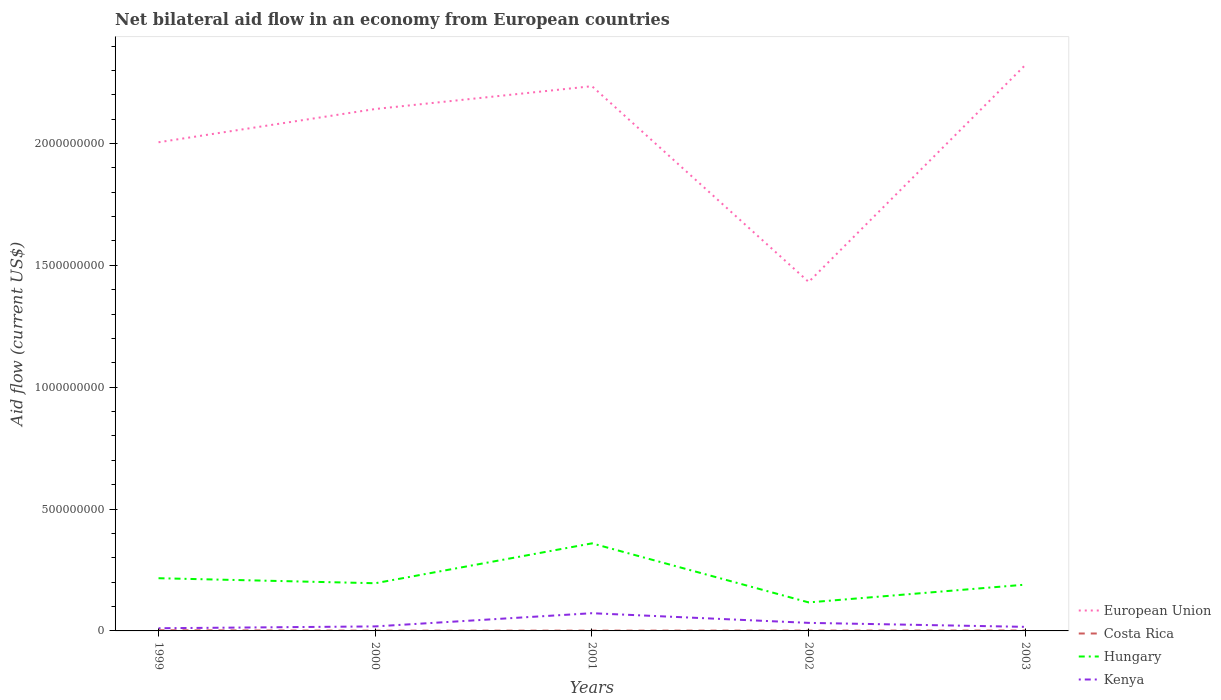Is the number of lines equal to the number of legend labels?
Your answer should be compact. Yes. Across all years, what is the maximum net bilateral aid flow in Hungary?
Your answer should be compact. 1.17e+08. What is the total net bilateral aid flow in Costa Rica in the graph?
Provide a short and direct response. 1.07e+06. What is the difference between the highest and the second highest net bilateral aid flow in Kenya?
Your response must be concise. 6.17e+07. What is the difference between the highest and the lowest net bilateral aid flow in Costa Rica?
Provide a succinct answer. 2. Is the net bilateral aid flow in Costa Rica strictly greater than the net bilateral aid flow in Hungary over the years?
Your answer should be compact. Yes. How many years are there in the graph?
Offer a very short reply. 5. Are the values on the major ticks of Y-axis written in scientific E-notation?
Your answer should be compact. No. Does the graph contain grids?
Provide a succinct answer. No. How many legend labels are there?
Your answer should be very brief. 4. What is the title of the graph?
Ensure brevity in your answer.  Net bilateral aid flow in an economy from European countries. Does "Slovenia" appear as one of the legend labels in the graph?
Your answer should be very brief. No. What is the Aid flow (current US$) in European Union in 1999?
Your answer should be compact. 2.01e+09. What is the Aid flow (current US$) of Costa Rica in 1999?
Make the answer very short. 2.82e+06. What is the Aid flow (current US$) of Hungary in 1999?
Your answer should be compact. 2.16e+08. What is the Aid flow (current US$) of Kenya in 1999?
Provide a short and direct response. 1.10e+07. What is the Aid flow (current US$) in European Union in 2000?
Keep it short and to the point. 2.14e+09. What is the Aid flow (current US$) in Costa Rica in 2000?
Provide a succinct answer. 1.12e+06. What is the Aid flow (current US$) of Hungary in 2000?
Give a very brief answer. 1.96e+08. What is the Aid flow (current US$) in Kenya in 2000?
Give a very brief answer. 1.86e+07. What is the Aid flow (current US$) in European Union in 2001?
Your response must be concise. 2.24e+09. What is the Aid flow (current US$) in Costa Rica in 2001?
Offer a very short reply. 1.27e+06. What is the Aid flow (current US$) in Hungary in 2001?
Your answer should be very brief. 3.59e+08. What is the Aid flow (current US$) in Kenya in 2001?
Your response must be concise. 7.27e+07. What is the Aid flow (current US$) of European Union in 2002?
Offer a terse response. 1.43e+09. What is the Aid flow (current US$) in Costa Rica in 2002?
Keep it short and to the point. 1.42e+06. What is the Aid flow (current US$) of Hungary in 2002?
Your answer should be compact. 1.17e+08. What is the Aid flow (current US$) of Kenya in 2002?
Offer a terse response. 3.30e+07. What is the Aid flow (current US$) of European Union in 2003?
Your answer should be compact. 2.32e+09. What is the Aid flow (current US$) of Costa Rica in 2003?
Provide a short and direct response. 1.75e+06. What is the Aid flow (current US$) of Hungary in 2003?
Make the answer very short. 1.90e+08. What is the Aid flow (current US$) in Kenya in 2003?
Offer a very short reply. 1.67e+07. Across all years, what is the maximum Aid flow (current US$) in European Union?
Your answer should be very brief. 2.32e+09. Across all years, what is the maximum Aid flow (current US$) of Costa Rica?
Offer a terse response. 2.82e+06. Across all years, what is the maximum Aid flow (current US$) of Hungary?
Your answer should be compact. 3.59e+08. Across all years, what is the maximum Aid flow (current US$) of Kenya?
Make the answer very short. 7.27e+07. Across all years, what is the minimum Aid flow (current US$) of European Union?
Your answer should be very brief. 1.43e+09. Across all years, what is the minimum Aid flow (current US$) in Costa Rica?
Your response must be concise. 1.12e+06. Across all years, what is the minimum Aid flow (current US$) in Hungary?
Offer a terse response. 1.17e+08. Across all years, what is the minimum Aid flow (current US$) of Kenya?
Provide a succinct answer. 1.10e+07. What is the total Aid flow (current US$) in European Union in the graph?
Offer a very short reply. 1.01e+1. What is the total Aid flow (current US$) of Costa Rica in the graph?
Ensure brevity in your answer.  8.38e+06. What is the total Aid flow (current US$) of Hungary in the graph?
Offer a very short reply. 1.08e+09. What is the total Aid flow (current US$) of Kenya in the graph?
Your answer should be compact. 1.52e+08. What is the difference between the Aid flow (current US$) of European Union in 1999 and that in 2000?
Give a very brief answer. -1.36e+08. What is the difference between the Aid flow (current US$) in Costa Rica in 1999 and that in 2000?
Keep it short and to the point. 1.70e+06. What is the difference between the Aid flow (current US$) in Hungary in 1999 and that in 2000?
Your answer should be compact. 2.06e+07. What is the difference between the Aid flow (current US$) in Kenya in 1999 and that in 2000?
Provide a short and direct response. -7.58e+06. What is the difference between the Aid flow (current US$) in European Union in 1999 and that in 2001?
Offer a terse response. -2.30e+08. What is the difference between the Aid flow (current US$) of Costa Rica in 1999 and that in 2001?
Provide a short and direct response. 1.55e+06. What is the difference between the Aid flow (current US$) in Hungary in 1999 and that in 2001?
Your response must be concise. -1.43e+08. What is the difference between the Aid flow (current US$) of Kenya in 1999 and that in 2001?
Your response must be concise. -6.17e+07. What is the difference between the Aid flow (current US$) of European Union in 1999 and that in 2002?
Provide a succinct answer. 5.73e+08. What is the difference between the Aid flow (current US$) in Costa Rica in 1999 and that in 2002?
Give a very brief answer. 1.40e+06. What is the difference between the Aid flow (current US$) in Hungary in 1999 and that in 2002?
Offer a terse response. 9.93e+07. What is the difference between the Aid flow (current US$) of Kenya in 1999 and that in 2002?
Offer a terse response. -2.21e+07. What is the difference between the Aid flow (current US$) of European Union in 1999 and that in 2003?
Your answer should be compact. -3.18e+08. What is the difference between the Aid flow (current US$) in Costa Rica in 1999 and that in 2003?
Your answer should be compact. 1.07e+06. What is the difference between the Aid flow (current US$) in Hungary in 1999 and that in 2003?
Offer a very short reply. 2.64e+07. What is the difference between the Aid flow (current US$) in Kenya in 1999 and that in 2003?
Give a very brief answer. -5.70e+06. What is the difference between the Aid flow (current US$) in European Union in 2000 and that in 2001?
Your answer should be very brief. -9.36e+07. What is the difference between the Aid flow (current US$) in Costa Rica in 2000 and that in 2001?
Your response must be concise. -1.50e+05. What is the difference between the Aid flow (current US$) in Hungary in 2000 and that in 2001?
Offer a very short reply. -1.64e+08. What is the difference between the Aid flow (current US$) of Kenya in 2000 and that in 2001?
Ensure brevity in your answer.  -5.41e+07. What is the difference between the Aid flow (current US$) in European Union in 2000 and that in 2002?
Provide a succinct answer. 7.10e+08. What is the difference between the Aid flow (current US$) of Costa Rica in 2000 and that in 2002?
Ensure brevity in your answer.  -3.00e+05. What is the difference between the Aid flow (current US$) of Hungary in 2000 and that in 2002?
Your answer should be compact. 7.87e+07. What is the difference between the Aid flow (current US$) of Kenya in 2000 and that in 2002?
Make the answer very short. -1.45e+07. What is the difference between the Aid flow (current US$) of European Union in 2000 and that in 2003?
Provide a succinct answer. -1.81e+08. What is the difference between the Aid flow (current US$) in Costa Rica in 2000 and that in 2003?
Give a very brief answer. -6.30e+05. What is the difference between the Aid flow (current US$) in Hungary in 2000 and that in 2003?
Your response must be concise. 5.76e+06. What is the difference between the Aid flow (current US$) in Kenya in 2000 and that in 2003?
Offer a very short reply. 1.88e+06. What is the difference between the Aid flow (current US$) of European Union in 2001 and that in 2002?
Your response must be concise. 8.03e+08. What is the difference between the Aid flow (current US$) in Costa Rica in 2001 and that in 2002?
Provide a succinct answer. -1.50e+05. What is the difference between the Aid flow (current US$) in Hungary in 2001 and that in 2002?
Your response must be concise. 2.42e+08. What is the difference between the Aid flow (current US$) of Kenya in 2001 and that in 2002?
Make the answer very short. 3.97e+07. What is the difference between the Aid flow (current US$) of European Union in 2001 and that in 2003?
Offer a very short reply. -8.75e+07. What is the difference between the Aid flow (current US$) in Costa Rica in 2001 and that in 2003?
Make the answer very short. -4.80e+05. What is the difference between the Aid flow (current US$) in Hungary in 2001 and that in 2003?
Give a very brief answer. 1.69e+08. What is the difference between the Aid flow (current US$) of Kenya in 2001 and that in 2003?
Ensure brevity in your answer.  5.60e+07. What is the difference between the Aid flow (current US$) of European Union in 2002 and that in 2003?
Your answer should be compact. -8.91e+08. What is the difference between the Aid flow (current US$) in Costa Rica in 2002 and that in 2003?
Make the answer very short. -3.30e+05. What is the difference between the Aid flow (current US$) in Hungary in 2002 and that in 2003?
Make the answer very short. -7.29e+07. What is the difference between the Aid flow (current US$) of Kenya in 2002 and that in 2003?
Your answer should be compact. 1.64e+07. What is the difference between the Aid flow (current US$) of European Union in 1999 and the Aid flow (current US$) of Costa Rica in 2000?
Keep it short and to the point. 2.00e+09. What is the difference between the Aid flow (current US$) in European Union in 1999 and the Aid flow (current US$) in Hungary in 2000?
Your response must be concise. 1.81e+09. What is the difference between the Aid flow (current US$) of European Union in 1999 and the Aid flow (current US$) of Kenya in 2000?
Offer a terse response. 1.99e+09. What is the difference between the Aid flow (current US$) in Costa Rica in 1999 and the Aid flow (current US$) in Hungary in 2000?
Provide a succinct answer. -1.93e+08. What is the difference between the Aid flow (current US$) of Costa Rica in 1999 and the Aid flow (current US$) of Kenya in 2000?
Keep it short and to the point. -1.57e+07. What is the difference between the Aid flow (current US$) in Hungary in 1999 and the Aid flow (current US$) in Kenya in 2000?
Give a very brief answer. 1.98e+08. What is the difference between the Aid flow (current US$) of European Union in 1999 and the Aid flow (current US$) of Costa Rica in 2001?
Provide a succinct answer. 2.00e+09. What is the difference between the Aid flow (current US$) in European Union in 1999 and the Aid flow (current US$) in Hungary in 2001?
Your answer should be very brief. 1.65e+09. What is the difference between the Aid flow (current US$) of European Union in 1999 and the Aid flow (current US$) of Kenya in 2001?
Offer a terse response. 1.93e+09. What is the difference between the Aid flow (current US$) in Costa Rica in 1999 and the Aid flow (current US$) in Hungary in 2001?
Your response must be concise. -3.56e+08. What is the difference between the Aid flow (current US$) in Costa Rica in 1999 and the Aid flow (current US$) in Kenya in 2001?
Give a very brief answer. -6.99e+07. What is the difference between the Aid flow (current US$) in Hungary in 1999 and the Aid flow (current US$) in Kenya in 2001?
Keep it short and to the point. 1.44e+08. What is the difference between the Aid flow (current US$) of European Union in 1999 and the Aid flow (current US$) of Costa Rica in 2002?
Give a very brief answer. 2.00e+09. What is the difference between the Aid flow (current US$) in European Union in 1999 and the Aid flow (current US$) in Hungary in 2002?
Make the answer very short. 1.89e+09. What is the difference between the Aid flow (current US$) of European Union in 1999 and the Aid flow (current US$) of Kenya in 2002?
Your response must be concise. 1.97e+09. What is the difference between the Aid flow (current US$) in Costa Rica in 1999 and the Aid flow (current US$) in Hungary in 2002?
Provide a succinct answer. -1.14e+08. What is the difference between the Aid flow (current US$) of Costa Rica in 1999 and the Aid flow (current US$) of Kenya in 2002?
Your answer should be compact. -3.02e+07. What is the difference between the Aid flow (current US$) in Hungary in 1999 and the Aid flow (current US$) in Kenya in 2002?
Ensure brevity in your answer.  1.83e+08. What is the difference between the Aid flow (current US$) in European Union in 1999 and the Aid flow (current US$) in Costa Rica in 2003?
Ensure brevity in your answer.  2.00e+09. What is the difference between the Aid flow (current US$) in European Union in 1999 and the Aid flow (current US$) in Hungary in 2003?
Keep it short and to the point. 1.82e+09. What is the difference between the Aid flow (current US$) of European Union in 1999 and the Aid flow (current US$) of Kenya in 2003?
Provide a succinct answer. 1.99e+09. What is the difference between the Aid flow (current US$) in Costa Rica in 1999 and the Aid flow (current US$) in Hungary in 2003?
Offer a terse response. -1.87e+08. What is the difference between the Aid flow (current US$) in Costa Rica in 1999 and the Aid flow (current US$) in Kenya in 2003?
Keep it short and to the point. -1.38e+07. What is the difference between the Aid flow (current US$) of Hungary in 1999 and the Aid flow (current US$) of Kenya in 2003?
Offer a terse response. 2.00e+08. What is the difference between the Aid flow (current US$) in European Union in 2000 and the Aid flow (current US$) in Costa Rica in 2001?
Provide a succinct answer. 2.14e+09. What is the difference between the Aid flow (current US$) in European Union in 2000 and the Aid flow (current US$) in Hungary in 2001?
Give a very brief answer. 1.78e+09. What is the difference between the Aid flow (current US$) of European Union in 2000 and the Aid flow (current US$) of Kenya in 2001?
Keep it short and to the point. 2.07e+09. What is the difference between the Aid flow (current US$) of Costa Rica in 2000 and the Aid flow (current US$) of Hungary in 2001?
Give a very brief answer. -3.58e+08. What is the difference between the Aid flow (current US$) in Costa Rica in 2000 and the Aid flow (current US$) in Kenya in 2001?
Your answer should be very brief. -7.16e+07. What is the difference between the Aid flow (current US$) of Hungary in 2000 and the Aid flow (current US$) of Kenya in 2001?
Provide a short and direct response. 1.23e+08. What is the difference between the Aid flow (current US$) in European Union in 2000 and the Aid flow (current US$) in Costa Rica in 2002?
Ensure brevity in your answer.  2.14e+09. What is the difference between the Aid flow (current US$) in European Union in 2000 and the Aid flow (current US$) in Hungary in 2002?
Ensure brevity in your answer.  2.02e+09. What is the difference between the Aid flow (current US$) of European Union in 2000 and the Aid flow (current US$) of Kenya in 2002?
Give a very brief answer. 2.11e+09. What is the difference between the Aid flow (current US$) in Costa Rica in 2000 and the Aid flow (current US$) in Hungary in 2002?
Offer a very short reply. -1.16e+08. What is the difference between the Aid flow (current US$) in Costa Rica in 2000 and the Aid flow (current US$) in Kenya in 2002?
Give a very brief answer. -3.19e+07. What is the difference between the Aid flow (current US$) in Hungary in 2000 and the Aid flow (current US$) in Kenya in 2002?
Ensure brevity in your answer.  1.63e+08. What is the difference between the Aid flow (current US$) in European Union in 2000 and the Aid flow (current US$) in Costa Rica in 2003?
Your response must be concise. 2.14e+09. What is the difference between the Aid flow (current US$) of European Union in 2000 and the Aid flow (current US$) of Hungary in 2003?
Offer a very short reply. 1.95e+09. What is the difference between the Aid flow (current US$) in European Union in 2000 and the Aid flow (current US$) in Kenya in 2003?
Ensure brevity in your answer.  2.12e+09. What is the difference between the Aid flow (current US$) in Costa Rica in 2000 and the Aid flow (current US$) in Hungary in 2003?
Ensure brevity in your answer.  -1.89e+08. What is the difference between the Aid flow (current US$) in Costa Rica in 2000 and the Aid flow (current US$) in Kenya in 2003?
Keep it short and to the point. -1.56e+07. What is the difference between the Aid flow (current US$) of Hungary in 2000 and the Aid flow (current US$) of Kenya in 2003?
Keep it short and to the point. 1.79e+08. What is the difference between the Aid flow (current US$) of European Union in 2001 and the Aid flow (current US$) of Costa Rica in 2002?
Give a very brief answer. 2.23e+09. What is the difference between the Aid flow (current US$) of European Union in 2001 and the Aid flow (current US$) of Hungary in 2002?
Provide a short and direct response. 2.12e+09. What is the difference between the Aid flow (current US$) of European Union in 2001 and the Aid flow (current US$) of Kenya in 2002?
Your answer should be compact. 2.20e+09. What is the difference between the Aid flow (current US$) of Costa Rica in 2001 and the Aid flow (current US$) of Hungary in 2002?
Ensure brevity in your answer.  -1.16e+08. What is the difference between the Aid flow (current US$) in Costa Rica in 2001 and the Aid flow (current US$) in Kenya in 2002?
Your response must be concise. -3.18e+07. What is the difference between the Aid flow (current US$) in Hungary in 2001 and the Aid flow (current US$) in Kenya in 2002?
Provide a short and direct response. 3.26e+08. What is the difference between the Aid flow (current US$) in European Union in 2001 and the Aid flow (current US$) in Costa Rica in 2003?
Offer a terse response. 2.23e+09. What is the difference between the Aid flow (current US$) in European Union in 2001 and the Aid flow (current US$) in Hungary in 2003?
Give a very brief answer. 2.05e+09. What is the difference between the Aid flow (current US$) of European Union in 2001 and the Aid flow (current US$) of Kenya in 2003?
Keep it short and to the point. 2.22e+09. What is the difference between the Aid flow (current US$) of Costa Rica in 2001 and the Aid flow (current US$) of Hungary in 2003?
Offer a terse response. -1.89e+08. What is the difference between the Aid flow (current US$) in Costa Rica in 2001 and the Aid flow (current US$) in Kenya in 2003?
Give a very brief answer. -1.54e+07. What is the difference between the Aid flow (current US$) of Hungary in 2001 and the Aid flow (current US$) of Kenya in 2003?
Provide a succinct answer. 3.43e+08. What is the difference between the Aid flow (current US$) of European Union in 2002 and the Aid flow (current US$) of Costa Rica in 2003?
Make the answer very short. 1.43e+09. What is the difference between the Aid flow (current US$) of European Union in 2002 and the Aid flow (current US$) of Hungary in 2003?
Provide a short and direct response. 1.24e+09. What is the difference between the Aid flow (current US$) of European Union in 2002 and the Aid flow (current US$) of Kenya in 2003?
Keep it short and to the point. 1.42e+09. What is the difference between the Aid flow (current US$) of Costa Rica in 2002 and the Aid flow (current US$) of Hungary in 2003?
Make the answer very short. -1.88e+08. What is the difference between the Aid flow (current US$) of Costa Rica in 2002 and the Aid flow (current US$) of Kenya in 2003?
Your answer should be very brief. -1.52e+07. What is the difference between the Aid flow (current US$) in Hungary in 2002 and the Aid flow (current US$) in Kenya in 2003?
Your answer should be compact. 1.00e+08. What is the average Aid flow (current US$) of European Union per year?
Offer a terse response. 2.03e+09. What is the average Aid flow (current US$) in Costa Rica per year?
Provide a succinct answer. 1.68e+06. What is the average Aid flow (current US$) of Hungary per year?
Give a very brief answer. 2.16e+08. What is the average Aid flow (current US$) of Kenya per year?
Offer a terse response. 3.04e+07. In the year 1999, what is the difference between the Aid flow (current US$) of European Union and Aid flow (current US$) of Costa Rica?
Ensure brevity in your answer.  2.00e+09. In the year 1999, what is the difference between the Aid flow (current US$) of European Union and Aid flow (current US$) of Hungary?
Keep it short and to the point. 1.79e+09. In the year 1999, what is the difference between the Aid flow (current US$) in European Union and Aid flow (current US$) in Kenya?
Offer a very short reply. 1.99e+09. In the year 1999, what is the difference between the Aid flow (current US$) of Costa Rica and Aid flow (current US$) of Hungary?
Your answer should be compact. -2.13e+08. In the year 1999, what is the difference between the Aid flow (current US$) of Costa Rica and Aid flow (current US$) of Kenya?
Make the answer very short. -8.15e+06. In the year 1999, what is the difference between the Aid flow (current US$) in Hungary and Aid flow (current US$) in Kenya?
Make the answer very short. 2.05e+08. In the year 2000, what is the difference between the Aid flow (current US$) of European Union and Aid flow (current US$) of Costa Rica?
Your response must be concise. 2.14e+09. In the year 2000, what is the difference between the Aid flow (current US$) in European Union and Aid flow (current US$) in Hungary?
Your response must be concise. 1.95e+09. In the year 2000, what is the difference between the Aid flow (current US$) of European Union and Aid flow (current US$) of Kenya?
Your response must be concise. 2.12e+09. In the year 2000, what is the difference between the Aid flow (current US$) in Costa Rica and Aid flow (current US$) in Hungary?
Provide a short and direct response. -1.95e+08. In the year 2000, what is the difference between the Aid flow (current US$) of Costa Rica and Aid flow (current US$) of Kenya?
Make the answer very short. -1.74e+07. In the year 2000, what is the difference between the Aid flow (current US$) of Hungary and Aid flow (current US$) of Kenya?
Make the answer very short. 1.77e+08. In the year 2001, what is the difference between the Aid flow (current US$) in European Union and Aid flow (current US$) in Costa Rica?
Keep it short and to the point. 2.23e+09. In the year 2001, what is the difference between the Aid flow (current US$) of European Union and Aid flow (current US$) of Hungary?
Your answer should be very brief. 1.88e+09. In the year 2001, what is the difference between the Aid flow (current US$) in European Union and Aid flow (current US$) in Kenya?
Provide a succinct answer. 2.16e+09. In the year 2001, what is the difference between the Aid flow (current US$) in Costa Rica and Aid flow (current US$) in Hungary?
Ensure brevity in your answer.  -3.58e+08. In the year 2001, what is the difference between the Aid flow (current US$) of Costa Rica and Aid flow (current US$) of Kenya?
Your response must be concise. -7.14e+07. In the year 2001, what is the difference between the Aid flow (current US$) in Hungary and Aid flow (current US$) in Kenya?
Provide a succinct answer. 2.87e+08. In the year 2002, what is the difference between the Aid flow (current US$) in European Union and Aid flow (current US$) in Costa Rica?
Provide a short and direct response. 1.43e+09. In the year 2002, what is the difference between the Aid flow (current US$) in European Union and Aid flow (current US$) in Hungary?
Offer a very short reply. 1.31e+09. In the year 2002, what is the difference between the Aid flow (current US$) in European Union and Aid flow (current US$) in Kenya?
Provide a succinct answer. 1.40e+09. In the year 2002, what is the difference between the Aid flow (current US$) of Costa Rica and Aid flow (current US$) of Hungary?
Make the answer very short. -1.16e+08. In the year 2002, what is the difference between the Aid flow (current US$) of Costa Rica and Aid flow (current US$) of Kenya?
Provide a short and direct response. -3.16e+07. In the year 2002, what is the difference between the Aid flow (current US$) of Hungary and Aid flow (current US$) of Kenya?
Provide a short and direct response. 8.40e+07. In the year 2003, what is the difference between the Aid flow (current US$) in European Union and Aid flow (current US$) in Costa Rica?
Make the answer very short. 2.32e+09. In the year 2003, what is the difference between the Aid flow (current US$) of European Union and Aid flow (current US$) of Hungary?
Give a very brief answer. 2.13e+09. In the year 2003, what is the difference between the Aid flow (current US$) of European Union and Aid flow (current US$) of Kenya?
Keep it short and to the point. 2.31e+09. In the year 2003, what is the difference between the Aid flow (current US$) in Costa Rica and Aid flow (current US$) in Hungary?
Give a very brief answer. -1.88e+08. In the year 2003, what is the difference between the Aid flow (current US$) of Costa Rica and Aid flow (current US$) of Kenya?
Ensure brevity in your answer.  -1.49e+07. In the year 2003, what is the difference between the Aid flow (current US$) in Hungary and Aid flow (current US$) in Kenya?
Provide a succinct answer. 1.73e+08. What is the ratio of the Aid flow (current US$) of European Union in 1999 to that in 2000?
Offer a very short reply. 0.94. What is the ratio of the Aid flow (current US$) in Costa Rica in 1999 to that in 2000?
Provide a short and direct response. 2.52. What is the ratio of the Aid flow (current US$) in Hungary in 1999 to that in 2000?
Your response must be concise. 1.11. What is the ratio of the Aid flow (current US$) in Kenya in 1999 to that in 2000?
Keep it short and to the point. 0.59. What is the ratio of the Aid flow (current US$) of European Union in 1999 to that in 2001?
Your response must be concise. 0.9. What is the ratio of the Aid flow (current US$) of Costa Rica in 1999 to that in 2001?
Offer a terse response. 2.22. What is the ratio of the Aid flow (current US$) of Hungary in 1999 to that in 2001?
Keep it short and to the point. 0.6. What is the ratio of the Aid flow (current US$) of Kenya in 1999 to that in 2001?
Your answer should be very brief. 0.15. What is the ratio of the Aid flow (current US$) of European Union in 1999 to that in 2002?
Ensure brevity in your answer.  1.4. What is the ratio of the Aid flow (current US$) of Costa Rica in 1999 to that in 2002?
Offer a very short reply. 1.99. What is the ratio of the Aid flow (current US$) in Hungary in 1999 to that in 2002?
Your answer should be very brief. 1.85. What is the ratio of the Aid flow (current US$) in Kenya in 1999 to that in 2002?
Your answer should be very brief. 0.33. What is the ratio of the Aid flow (current US$) in European Union in 1999 to that in 2003?
Ensure brevity in your answer.  0.86. What is the ratio of the Aid flow (current US$) of Costa Rica in 1999 to that in 2003?
Your answer should be very brief. 1.61. What is the ratio of the Aid flow (current US$) in Hungary in 1999 to that in 2003?
Provide a succinct answer. 1.14. What is the ratio of the Aid flow (current US$) in Kenya in 1999 to that in 2003?
Your answer should be compact. 0.66. What is the ratio of the Aid flow (current US$) in European Union in 2000 to that in 2001?
Ensure brevity in your answer.  0.96. What is the ratio of the Aid flow (current US$) of Costa Rica in 2000 to that in 2001?
Provide a succinct answer. 0.88. What is the ratio of the Aid flow (current US$) in Hungary in 2000 to that in 2001?
Make the answer very short. 0.54. What is the ratio of the Aid flow (current US$) in Kenya in 2000 to that in 2001?
Offer a terse response. 0.26. What is the ratio of the Aid flow (current US$) of European Union in 2000 to that in 2002?
Give a very brief answer. 1.5. What is the ratio of the Aid flow (current US$) in Costa Rica in 2000 to that in 2002?
Keep it short and to the point. 0.79. What is the ratio of the Aid flow (current US$) of Hungary in 2000 to that in 2002?
Give a very brief answer. 1.67. What is the ratio of the Aid flow (current US$) in Kenya in 2000 to that in 2002?
Ensure brevity in your answer.  0.56. What is the ratio of the Aid flow (current US$) of European Union in 2000 to that in 2003?
Offer a very short reply. 0.92. What is the ratio of the Aid flow (current US$) in Costa Rica in 2000 to that in 2003?
Ensure brevity in your answer.  0.64. What is the ratio of the Aid flow (current US$) of Hungary in 2000 to that in 2003?
Give a very brief answer. 1.03. What is the ratio of the Aid flow (current US$) of Kenya in 2000 to that in 2003?
Ensure brevity in your answer.  1.11. What is the ratio of the Aid flow (current US$) in European Union in 2001 to that in 2002?
Ensure brevity in your answer.  1.56. What is the ratio of the Aid flow (current US$) of Costa Rica in 2001 to that in 2002?
Ensure brevity in your answer.  0.89. What is the ratio of the Aid flow (current US$) of Hungary in 2001 to that in 2002?
Your answer should be compact. 3.07. What is the ratio of the Aid flow (current US$) of Kenya in 2001 to that in 2002?
Provide a succinct answer. 2.2. What is the ratio of the Aid flow (current US$) in European Union in 2001 to that in 2003?
Offer a terse response. 0.96. What is the ratio of the Aid flow (current US$) in Costa Rica in 2001 to that in 2003?
Make the answer very short. 0.73. What is the ratio of the Aid flow (current US$) of Hungary in 2001 to that in 2003?
Your answer should be compact. 1.89. What is the ratio of the Aid flow (current US$) in Kenya in 2001 to that in 2003?
Provide a succinct answer. 4.36. What is the ratio of the Aid flow (current US$) in European Union in 2002 to that in 2003?
Your answer should be compact. 0.62. What is the ratio of the Aid flow (current US$) of Costa Rica in 2002 to that in 2003?
Offer a terse response. 0.81. What is the ratio of the Aid flow (current US$) in Hungary in 2002 to that in 2003?
Give a very brief answer. 0.62. What is the ratio of the Aid flow (current US$) of Kenya in 2002 to that in 2003?
Ensure brevity in your answer.  1.98. What is the difference between the highest and the second highest Aid flow (current US$) of European Union?
Your response must be concise. 8.75e+07. What is the difference between the highest and the second highest Aid flow (current US$) in Costa Rica?
Offer a terse response. 1.07e+06. What is the difference between the highest and the second highest Aid flow (current US$) in Hungary?
Your answer should be compact. 1.43e+08. What is the difference between the highest and the second highest Aid flow (current US$) of Kenya?
Offer a very short reply. 3.97e+07. What is the difference between the highest and the lowest Aid flow (current US$) in European Union?
Ensure brevity in your answer.  8.91e+08. What is the difference between the highest and the lowest Aid flow (current US$) in Costa Rica?
Offer a very short reply. 1.70e+06. What is the difference between the highest and the lowest Aid flow (current US$) of Hungary?
Offer a very short reply. 2.42e+08. What is the difference between the highest and the lowest Aid flow (current US$) in Kenya?
Make the answer very short. 6.17e+07. 